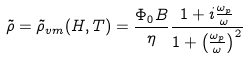<formula> <loc_0><loc_0><loc_500><loc_500>\tilde { \rho } = \tilde { \rho } _ { v m } ( H , T ) = \frac { \Phi _ { 0 } B } { \eta } \frac { 1 + i \frac { \omega _ { p } } { \omega } } { 1 + \left ( \frac { \omega _ { p } } { \omega } \right ) ^ { 2 } }</formula> 